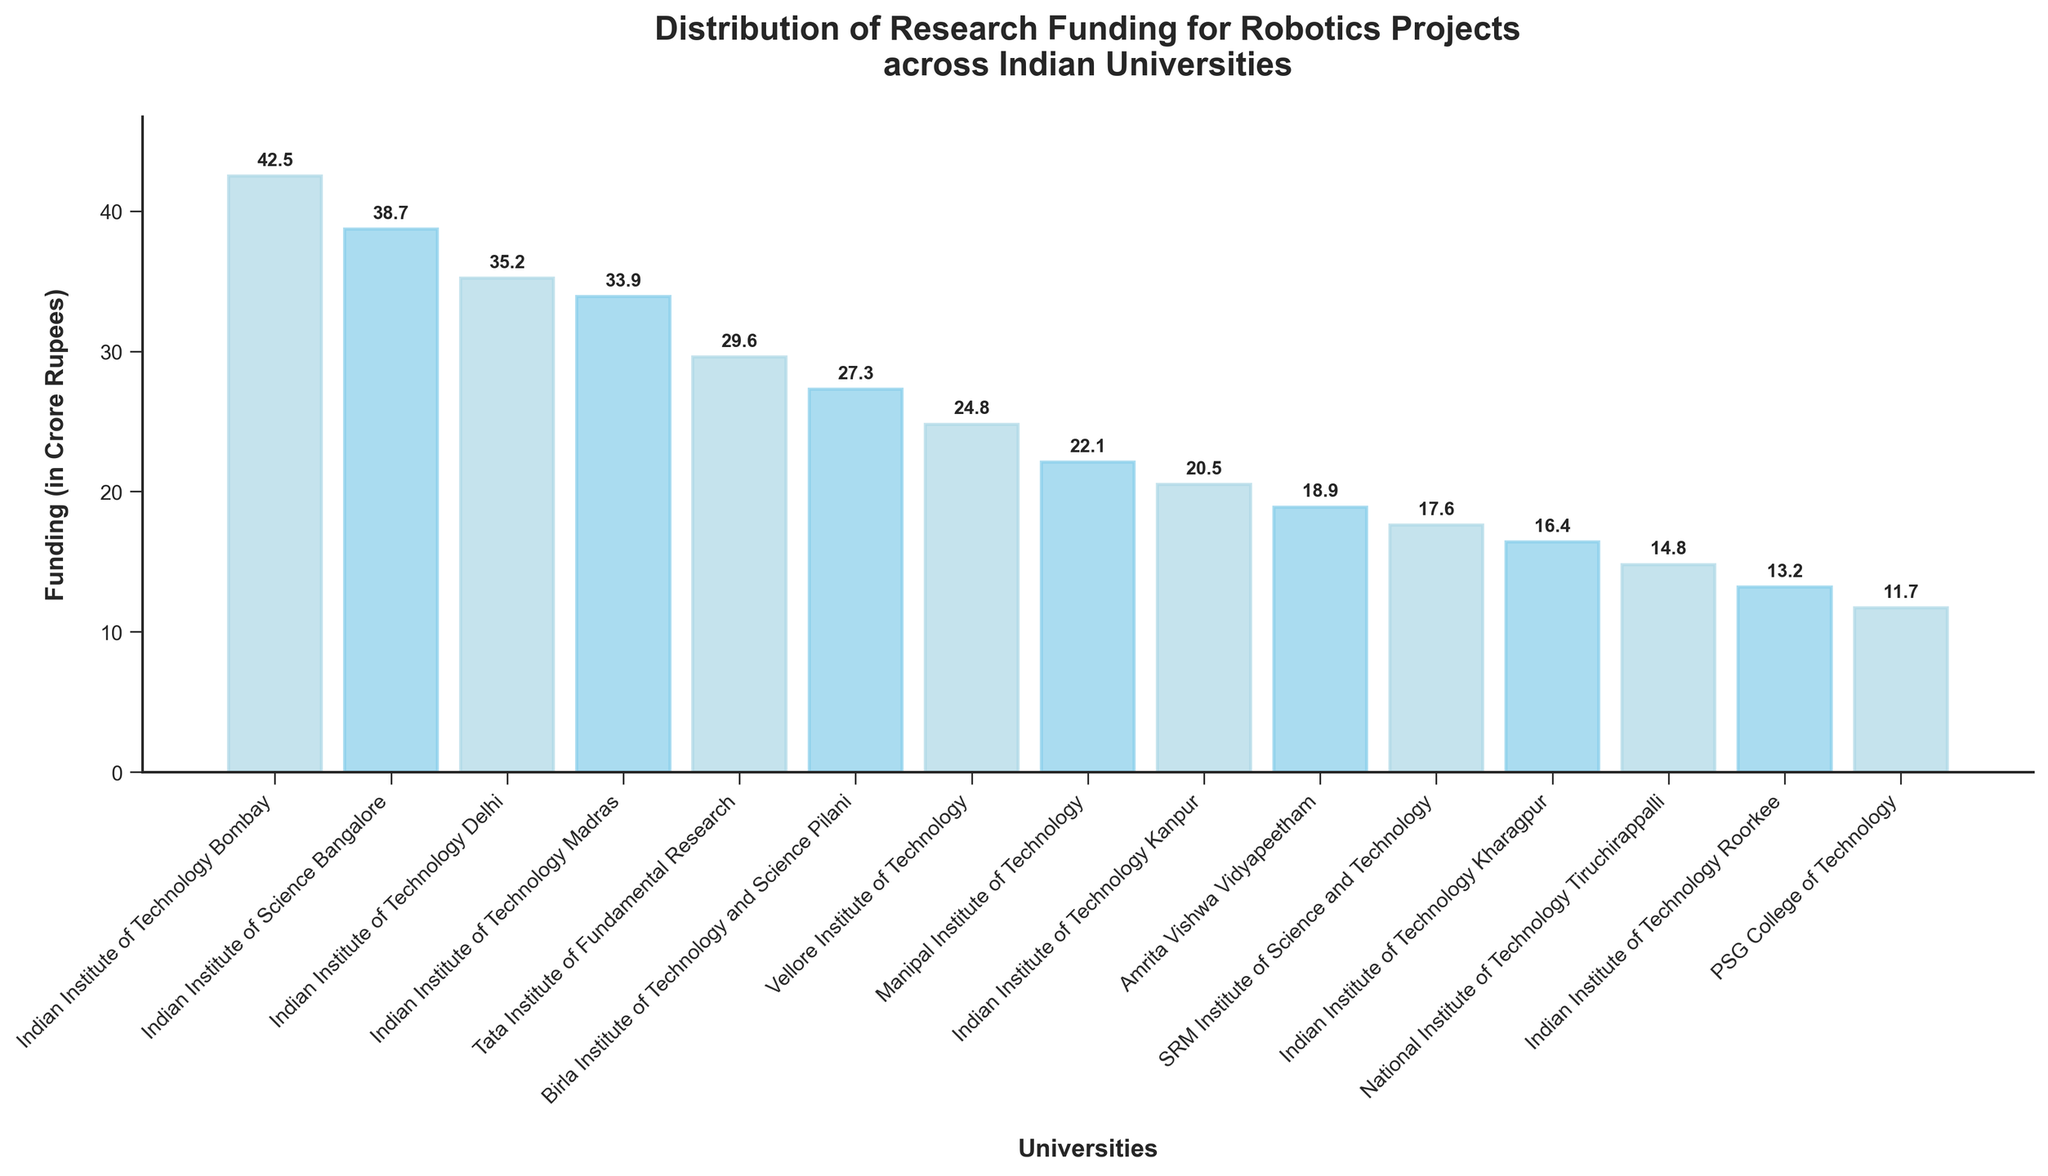Which university received the highest funding? The highest bar in the chart is labeled "Indian Institute of Technology Bombay" with a funding of 42.5 crore Rupees.
Answer: Indian Institute of Technology Bombay Which university has the smallest amount of funding? The shortest bar in the chart is labeled "PSG College of Technology" with a funding of 11.7 crore Rupees.
Answer: PSG College of Technology What is the total funding for universities with more than 30 crore Rupees in funding? Identify universities with funding greater than 30 crore Rupees (IIT Bombay, IISc Bangalore, IIT Delhi, IIT Madras) and sum their funding: 42.5 + 38.7 + 35.2 + 33.9 = 150.3 crore Rupees.
Answer: 150.3 crore Rupees How does the funding of Vellore Institute of Technology compare to Manipal Institute of Technology? Vellore Institute of Technology has a funding of 24.8 crore Rupees while Manipal Institute of Technology has 22.1 crore Rupees. 24.8 is greater than 22.1.
Answer: Vellore Institute of Technology has more funding than Manipal Institute of Technology Which universities have funding between 20 and 30 crore Rupees? Identify universities with funding within the range: {Birla Institute of Technology and Science Pilani: 27.3, Vellore Institute of Technology: 24.8, Manipal Institute of Technology: 22.1, Indian Institute of Technology Kanpur: 20.5}
Answer: Birla Institute of Technology and Science Pilani, Vellore Institute of Technology, Manipal Institute of Technology, Indian Institute of Technology Kanpur What is the difference in funding between the Indian Institute of Technology Delhi and the Tata Institute of Fundamental Research? IIT Delhi has 35.2 crore Rupees, and TIFR has 29.6 crore Rupees. The difference is 35.2 - 29.6 = 5.6 crore Rupees.
Answer: 5.6 crore Rupees What is the average funding amount among all universities? Sum total funding of all universities and divide by count: (42.5 + 38.7 + 35.2 + 33.9 + 29.6 + 27.3 + 24.8 + 22.1 + 20.5 + 18.9 + 17.6 + 16.4 + 14.8 + 13.2 + 11.7) / 15 = 315.2 / 15 ≈ 21.0 crore Rupees.
Answer: 21.0 crore Rupees 